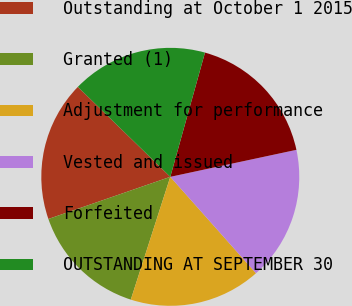Convert chart to OTSL. <chart><loc_0><loc_0><loc_500><loc_500><pie_chart><fcel>Outstanding at October 1 2015<fcel>Granted (1)<fcel>Adjustment for performance<fcel>Vested and issued<fcel>Forfeited<fcel>OUTSTANDING AT SEPTEMBER 30<nl><fcel>17.58%<fcel>14.75%<fcel>16.52%<fcel>16.79%<fcel>17.31%<fcel>17.05%<nl></chart> 